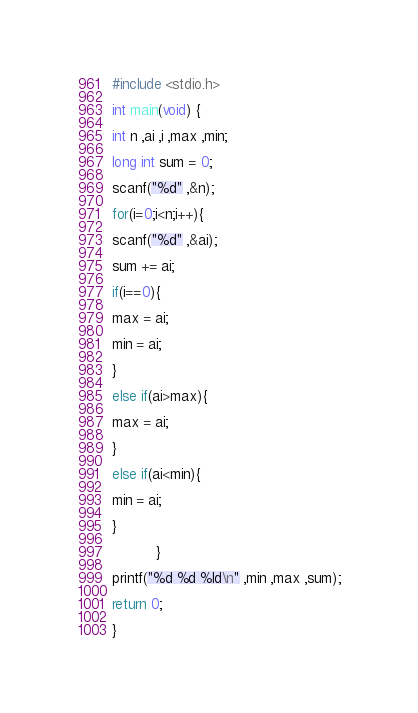<code> <loc_0><loc_0><loc_500><loc_500><_C_>#include <stdio.h>

int main(void) {  

int n ,ai ,i ,max ,min;          

long int sum = 0;    

scanf("%d" ,&n);    

for(i=0;i<n;i++){      

scanf("%d" ,&ai);      

sum += ai;      

if(i==0){        

max = ai;                        

min = ai;

}      

else if(ai>max){        

max = ai;      

}      

else if(ai<min){        

min = ai;       

}

          } 
   
printf("%d %d %ld\n" ,min ,max ,sum);
      
return 0;     

}     </code> 